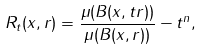Convert formula to latex. <formula><loc_0><loc_0><loc_500><loc_500>R _ { t } ( x , r ) = \frac { \mu ( B ( x , t r ) ) } { \mu ( B ( x , r ) ) } - t ^ { n } ,</formula> 